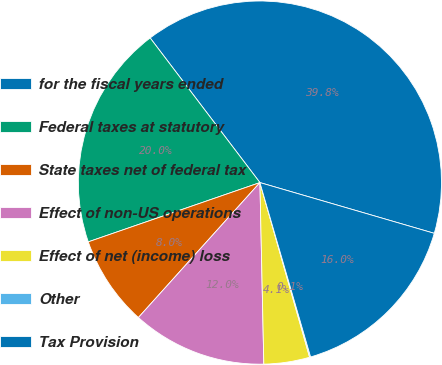<chart> <loc_0><loc_0><loc_500><loc_500><pie_chart><fcel>for the fiscal years ended<fcel>Federal taxes at statutory<fcel>State taxes net of federal tax<fcel>Effect of non-US operations<fcel>Effect of net (income) loss<fcel>Other<fcel>Tax Provision<nl><fcel>39.84%<fcel>19.96%<fcel>8.04%<fcel>12.01%<fcel>4.07%<fcel>0.09%<fcel>15.99%<nl></chart> 